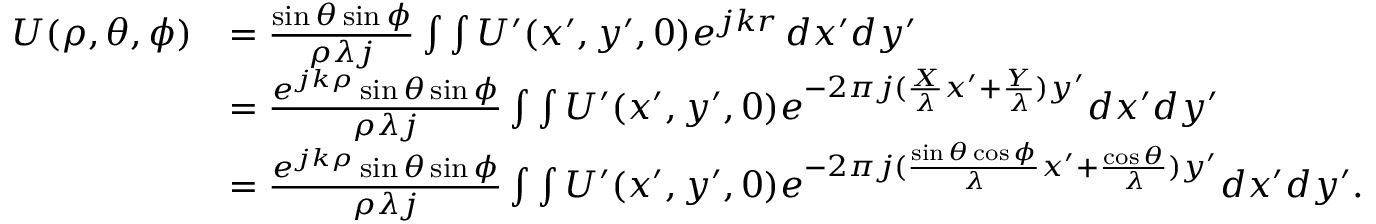Convert formula to latex. <formula><loc_0><loc_0><loc_500><loc_500>\begin{array} { r l } { U ( \rho , \theta , \phi ) } & { = \frac { \sin { \theta } \sin { \phi } } { \rho \lambda j } \int \int U ^ { \prime } ( x ^ { \prime } , y ^ { \prime } , 0 ) { e ^ { j k r } } \, d x ^ { \prime } d y ^ { \prime } } \\ & { = \frac { e ^ { j k \rho } \sin { \theta } \sin { \phi } } { \rho \lambda j } \int \int U ^ { \prime } ( x ^ { \prime } , y ^ { \prime } , 0 ) e ^ { - 2 \pi j ( \frac { X } { \lambda } x ^ { \prime } + \frac { Y } { \lambda } ) y ^ { \prime } } d x ^ { \prime } d y ^ { \prime } } \\ & { = \frac { e ^ { j k \rho } \sin { \theta } \sin { \phi } } { \rho \lambda j } \int \int U ^ { \prime } ( x ^ { \prime } , y ^ { \prime } , 0 ) e ^ { - 2 \pi j ( \frac { \sin { \theta } \cos { \phi } } { \lambda } x ^ { \prime } + \frac { \cos { \theta } } { \lambda } ) y ^ { \prime } } d x ^ { \prime } d y ^ { \prime } . } \end{array}</formula> 